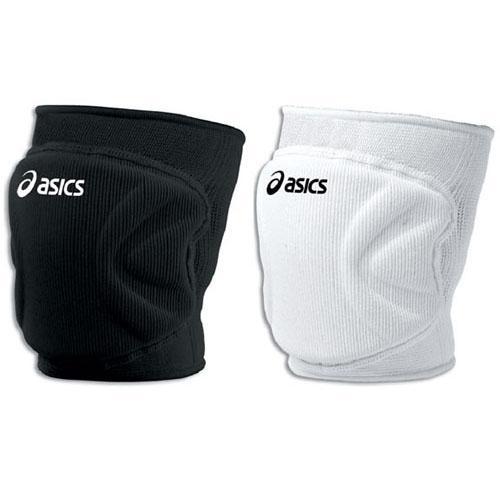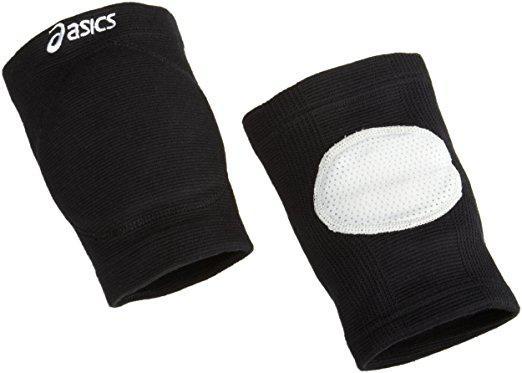The first image is the image on the left, the second image is the image on the right. Examine the images to the left and right. Is the description "There is at least one white protective pad." accurate? Answer yes or no. Yes. The first image is the image on the left, the second image is the image on the right. Analyze the images presented: Is the assertion "There are three or fewer black knee pads." valid? Answer yes or no. Yes. The first image is the image on the left, the second image is the image on the right. Analyze the images presented: Is the assertion "One image shows a black knee pad with a white logo and like a white knee pad with a black logo." valid? Answer yes or no. Yes. 